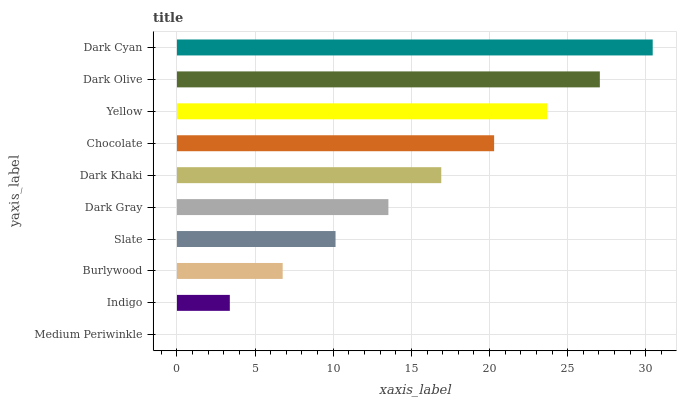Is Medium Periwinkle the minimum?
Answer yes or no. Yes. Is Dark Cyan the maximum?
Answer yes or no. Yes. Is Indigo the minimum?
Answer yes or no. No. Is Indigo the maximum?
Answer yes or no. No. Is Indigo greater than Medium Periwinkle?
Answer yes or no. Yes. Is Medium Periwinkle less than Indigo?
Answer yes or no. Yes. Is Medium Periwinkle greater than Indigo?
Answer yes or no. No. Is Indigo less than Medium Periwinkle?
Answer yes or no. No. Is Dark Khaki the high median?
Answer yes or no. Yes. Is Dark Gray the low median?
Answer yes or no. Yes. Is Slate the high median?
Answer yes or no. No. Is Burlywood the low median?
Answer yes or no. No. 